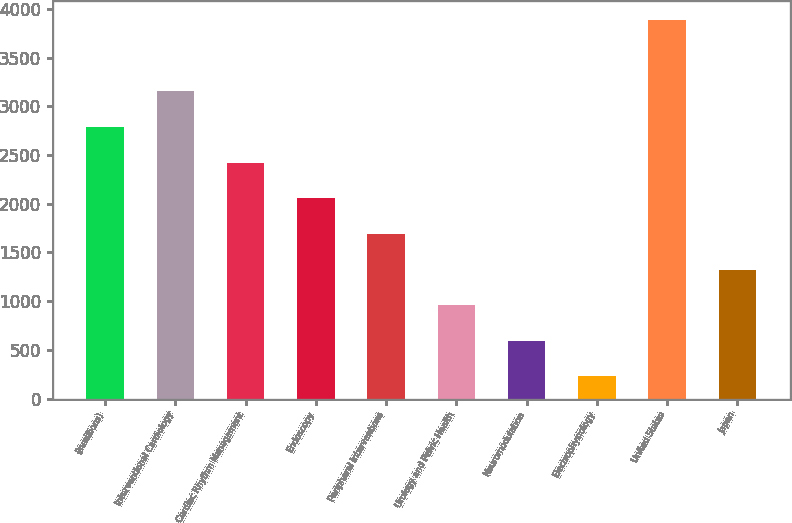<chart> <loc_0><loc_0><loc_500><loc_500><bar_chart><fcel>(inmillions)<fcel>Interventional Cardiology<fcel>Cardiac Rhythm Management<fcel>Endoscopy<fcel>Peripheral Interventions<fcel>Urology and Pelvic Health<fcel>Neuromodulation<fcel>Electrophysiology<fcel>United States<fcel>Japan<nl><fcel>2787.6<fcel>3153.4<fcel>2421.8<fcel>2056<fcel>1690.2<fcel>958.6<fcel>592.8<fcel>227<fcel>3885<fcel>1324.4<nl></chart> 